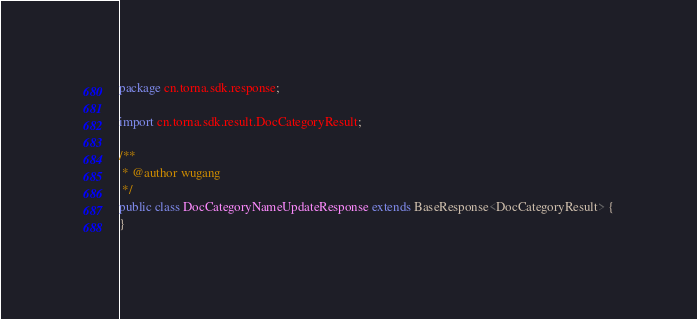<code> <loc_0><loc_0><loc_500><loc_500><_Java_>package cn.torna.sdk.response;

import cn.torna.sdk.result.DocCategoryResult;

/**
 * @author wugang
 */
public class DocCategoryNameUpdateResponse extends BaseResponse<DocCategoryResult> {
}
</code> 